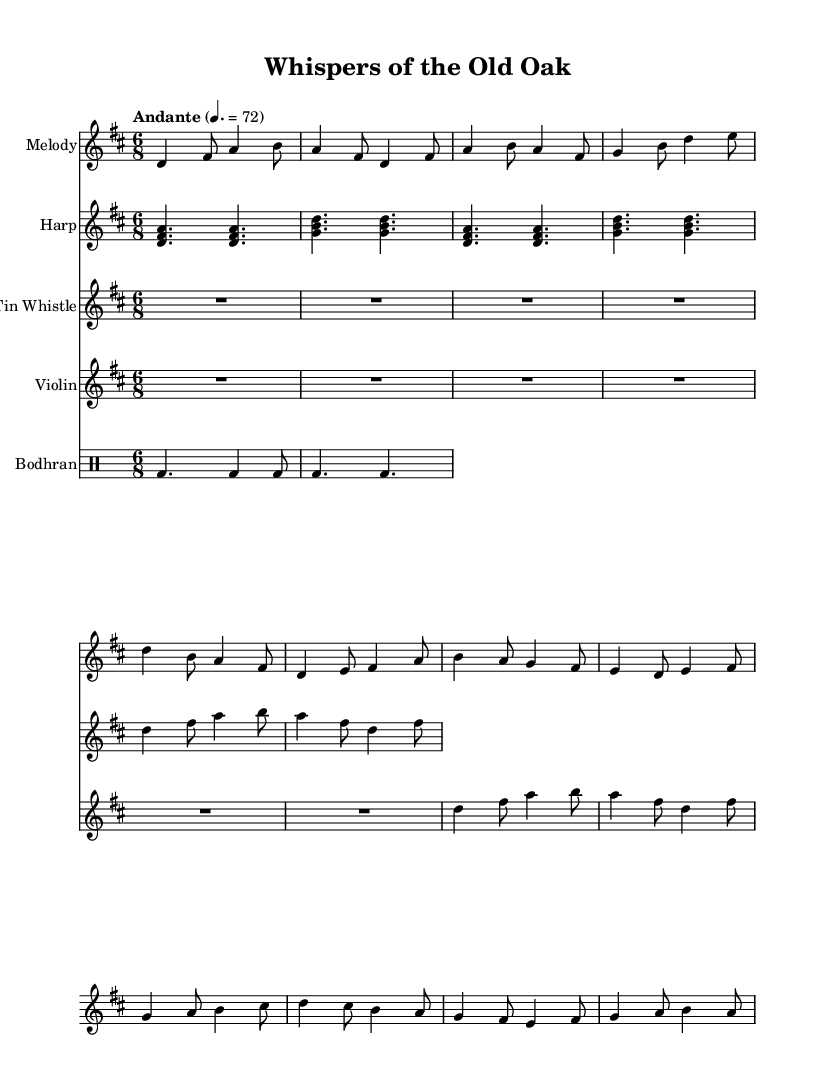What is the key signature of this music? The key signature is indicated at the beginning of the piece, showing two sharps, which correspond to the notes F# and C#. This means the music is in D major.
Answer: D major What is the time signature of this music? The time signature is shown at the beginning of the piece as a fraction of 6 over 8. This indicates the music has 6 beats in each measure, with each beat being an eighth note.
Answer: 6/8 What is the tempo marking for this piece? The tempo marking is provided in the score as "Andante" followed by a metronome marking of 72. This indicates a moderate pace of the music.
Answer: Andante 72 How many instruments are indicated in the score? The score shows five individual staves, each representing a different instrument: Melody, Harp, Tin Whistle, Violin, and Bodhran. Thus, there are five instruments in total.
Answer: Five What is the main theme of this piece? The title "Whispers of the Old Oak" suggests a narrative or storytelling element that is common in Celtic folk music, indicating a connection to nature or folklore, which aligns with the relaxing theme.
Answer: Storytelling What type of rhythm is primarily used in this piece? The rhythmic structure is characterized by its compound meter due to the time signature of 6/8, which creates a flowing and lilting feel typical in Celtic music.
Answer: Compound meter Which instrument has a drum part in the score? The Bodhran is the instrument that provides the drum part in the score, indicated by the different notation style and specific drum notation.
Answer: Bodhran 